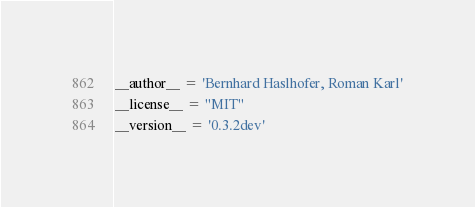<code> <loc_0><loc_0><loc_500><loc_500><_Python_>
__author__ = 'Bernhard Haslhofer, Roman Karl'
__license__ = "MIT"
__version__ = '0.3.2dev'
</code> 